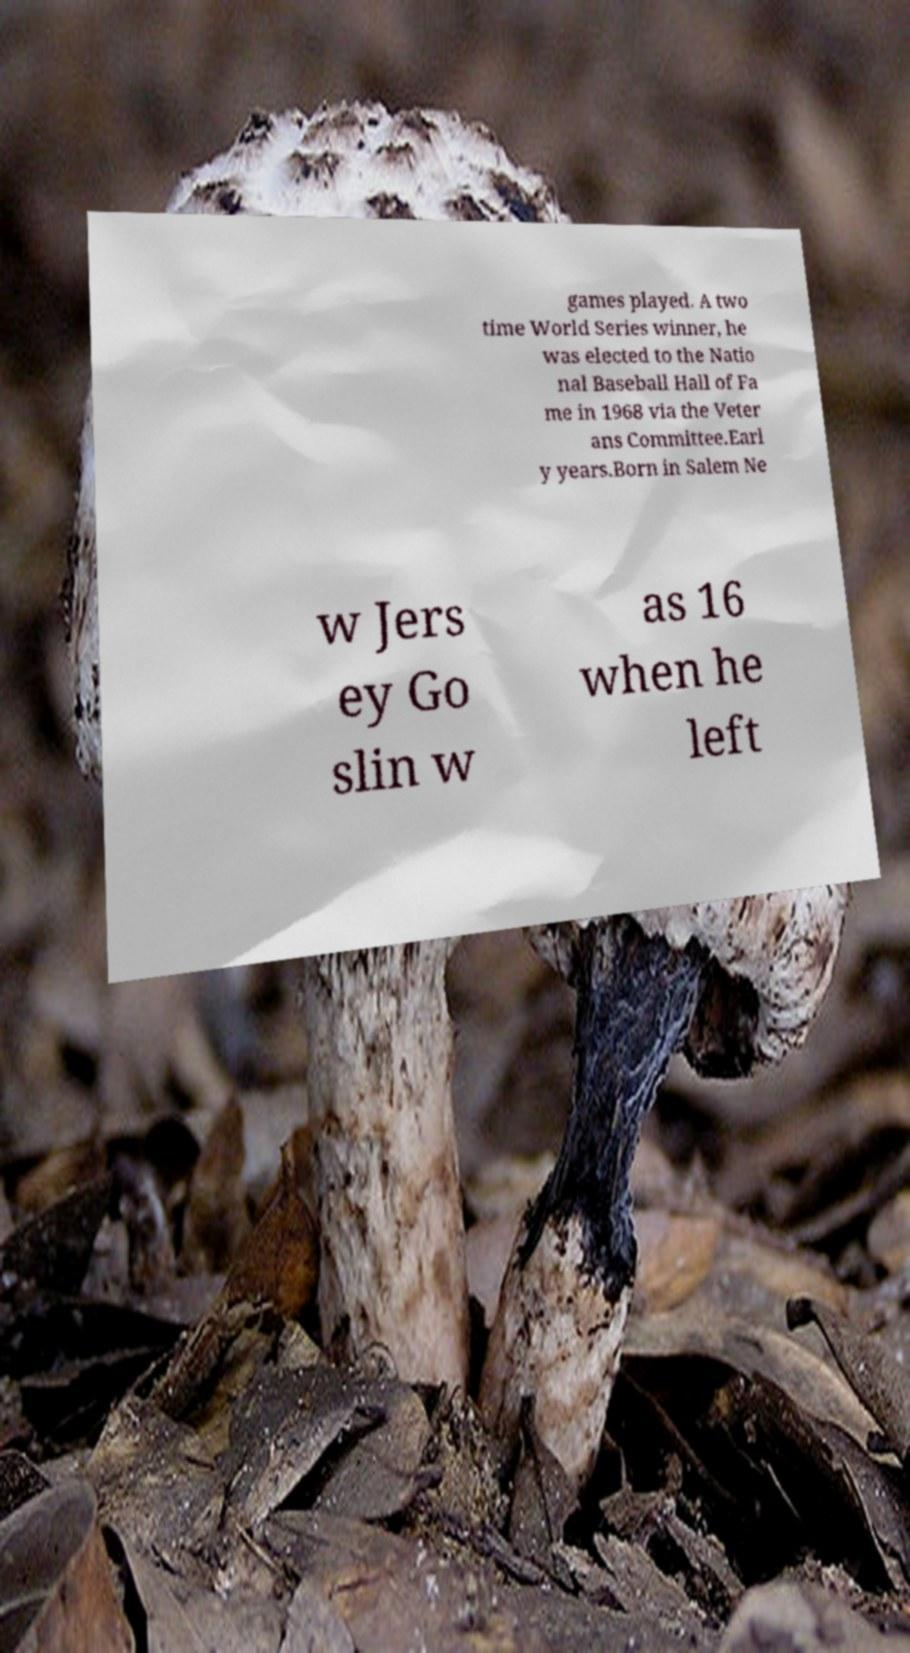Please identify and transcribe the text found in this image. games played. A two time World Series winner, he was elected to the Natio nal Baseball Hall of Fa me in 1968 via the Veter ans Committee.Earl y years.Born in Salem Ne w Jers ey Go slin w as 16 when he left 